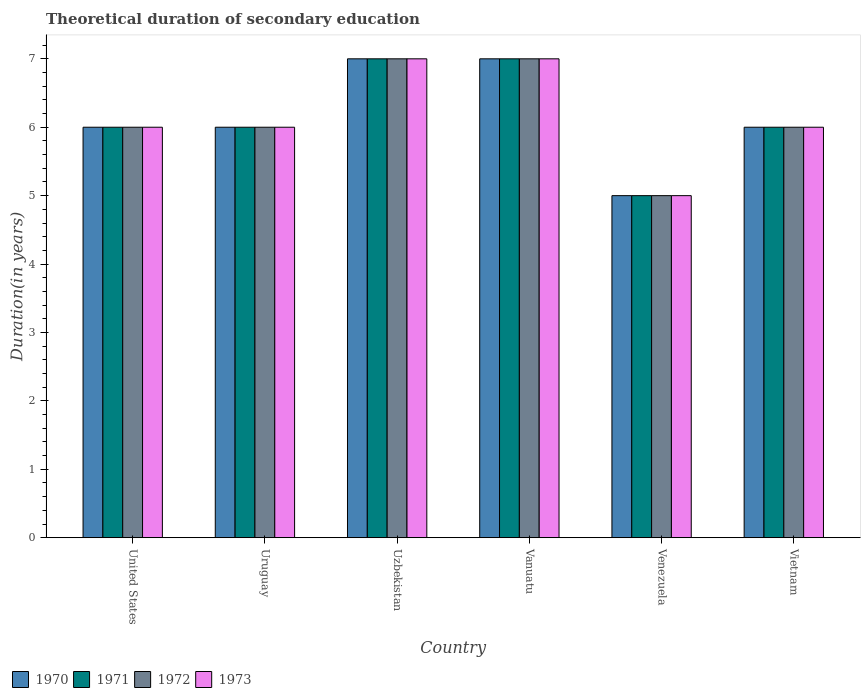How many different coloured bars are there?
Give a very brief answer. 4. Are the number of bars on each tick of the X-axis equal?
Offer a very short reply. Yes. How many bars are there on the 6th tick from the left?
Make the answer very short. 4. What is the label of the 3rd group of bars from the left?
Your response must be concise. Uzbekistan. In how many cases, is the number of bars for a given country not equal to the number of legend labels?
Offer a very short reply. 0. What is the total theoretical duration of secondary education in 1973 in Vietnam?
Provide a succinct answer. 6. Across all countries, what is the maximum total theoretical duration of secondary education in 1972?
Offer a terse response. 7. Across all countries, what is the minimum total theoretical duration of secondary education in 1971?
Provide a short and direct response. 5. In which country was the total theoretical duration of secondary education in 1971 maximum?
Keep it short and to the point. Uzbekistan. In which country was the total theoretical duration of secondary education in 1971 minimum?
Give a very brief answer. Venezuela. What is the total total theoretical duration of secondary education in 1973 in the graph?
Provide a short and direct response. 37. What is the difference between the total theoretical duration of secondary education in 1970 in United States and that in Vietnam?
Give a very brief answer. 0. What is the difference between the total theoretical duration of secondary education in 1971 in Vietnam and the total theoretical duration of secondary education in 1970 in United States?
Ensure brevity in your answer.  0. What is the average total theoretical duration of secondary education in 1970 per country?
Your answer should be compact. 6.17. In how many countries, is the total theoretical duration of secondary education in 1971 greater than 3.4 years?
Your answer should be very brief. 6. What is the ratio of the total theoretical duration of secondary education in 1972 in Vanuatu to that in Vietnam?
Provide a short and direct response. 1.17. Is the difference between the total theoretical duration of secondary education in 1971 in Vanuatu and Vietnam greater than the difference between the total theoretical duration of secondary education in 1972 in Vanuatu and Vietnam?
Your answer should be very brief. No. What is the difference between the highest and the second highest total theoretical duration of secondary education in 1972?
Offer a very short reply. -1. In how many countries, is the total theoretical duration of secondary education in 1970 greater than the average total theoretical duration of secondary education in 1970 taken over all countries?
Provide a succinct answer. 2. Is it the case that in every country, the sum of the total theoretical duration of secondary education in 1971 and total theoretical duration of secondary education in 1973 is greater than the sum of total theoretical duration of secondary education in 1972 and total theoretical duration of secondary education in 1970?
Offer a very short reply. No. What does the 3rd bar from the right in Venezuela represents?
Give a very brief answer. 1971. Are all the bars in the graph horizontal?
Give a very brief answer. No. How many countries are there in the graph?
Give a very brief answer. 6. How are the legend labels stacked?
Provide a succinct answer. Horizontal. What is the title of the graph?
Ensure brevity in your answer.  Theoretical duration of secondary education. What is the label or title of the Y-axis?
Provide a succinct answer. Duration(in years). What is the Duration(in years) in 1970 in United States?
Make the answer very short. 6. What is the Duration(in years) in 1972 in United States?
Keep it short and to the point. 6. What is the Duration(in years) in 1973 in United States?
Make the answer very short. 6. What is the Duration(in years) of 1970 in Uruguay?
Ensure brevity in your answer.  6. What is the Duration(in years) of 1972 in Vanuatu?
Offer a terse response. 7. What is the Duration(in years) of 1971 in Venezuela?
Your response must be concise. 5. What is the Duration(in years) of 1973 in Venezuela?
Keep it short and to the point. 5. What is the Duration(in years) in 1970 in Vietnam?
Your answer should be very brief. 6. What is the Duration(in years) of 1973 in Vietnam?
Your response must be concise. 6. Across all countries, what is the maximum Duration(in years) in 1970?
Provide a short and direct response. 7. Across all countries, what is the maximum Duration(in years) in 1971?
Your response must be concise. 7. Across all countries, what is the maximum Duration(in years) in 1972?
Your answer should be compact. 7. Across all countries, what is the maximum Duration(in years) in 1973?
Keep it short and to the point. 7. What is the total Duration(in years) of 1970 in the graph?
Your answer should be very brief. 37. What is the total Duration(in years) in 1971 in the graph?
Your response must be concise. 37. What is the difference between the Duration(in years) of 1972 in United States and that in Uruguay?
Offer a very short reply. 0. What is the difference between the Duration(in years) of 1973 in United States and that in Uruguay?
Ensure brevity in your answer.  0. What is the difference between the Duration(in years) in 1970 in United States and that in Uzbekistan?
Your answer should be compact. -1. What is the difference between the Duration(in years) in 1971 in United States and that in Uzbekistan?
Offer a very short reply. -1. What is the difference between the Duration(in years) of 1970 in United States and that in Vanuatu?
Make the answer very short. -1. What is the difference between the Duration(in years) in 1971 in United States and that in Vanuatu?
Offer a very short reply. -1. What is the difference between the Duration(in years) in 1973 in United States and that in Vanuatu?
Keep it short and to the point. -1. What is the difference between the Duration(in years) in 1970 in United States and that in Venezuela?
Ensure brevity in your answer.  1. What is the difference between the Duration(in years) of 1972 in United States and that in Venezuela?
Your response must be concise. 1. What is the difference between the Duration(in years) in 1973 in United States and that in Venezuela?
Your answer should be very brief. 1. What is the difference between the Duration(in years) of 1970 in United States and that in Vietnam?
Your response must be concise. 0. What is the difference between the Duration(in years) in 1971 in United States and that in Vietnam?
Provide a succinct answer. 0. What is the difference between the Duration(in years) of 1973 in United States and that in Vietnam?
Your response must be concise. 0. What is the difference between the Duration(in years) in 1972 in Uruguay and that in Uzbekistan?
Your answer should be compact. -1. What is the difference between the Duration(in years) in 1973 in Uruguay and that in Uzbekistan?
Your response must be concise. -1. What is the difference between the Duration(in years) of 1972 in Uruguay and that in Vanuatu?
Your answer should be very brief. -1. What is the difference between the Duration(in years) in 1973 in Uruguay and that in Vanuatu?
Ensure brevity in your answer.  -1. What is the difference between the Duration(in years) in 1970 in Uruguay and that in Venezuela?
Give a very brief answer. 1. What is the difference between the Duration(in years) of 1973 in Uruguay and that in Venezuela?
Keep it short and to the point. 1. What is the difference between the Duration(in years) in 1970 in Uruguay and that in Vietnam?
Keep it short and to the point. 0. What is the difference between the Duration(in years) in 1972 in Uruguay and that in Vietnam?
Your answer should be very brief. 0. What is the difference between the Duration(in years) in 1970 in Uzbekistan and that in Vanuatu?
Provide a succinct answer. 0. What is the difference between the Duration(in years) in 1971 in Uzbekistan and that in Vanuatu?
Offer a very short reply. 0. What is the difference between the Duration(in years) in 1972 in Uzbekistan and that in Vanuatu?
Offer a very short reply. 0. What is the difference between the Duration(in years) in 1973 in Uzbekistan and that in Vanuatu?
Make the answer very short. 0. What is the difference between the Duration(in years) in 1970 in Uzbekistan and that in Venezuela?
Provide a short and direct response. 2. What is the difference between the Duration(in years) of 1971 in Uzbekistan and that in Venezuela?
Offer a very short reply. 2. What is the difference between the Duration(in years) of 1972 in Uzbekistan and that in Venezuela?
Offer a terse response. 2. What is the difference between the Duration(in years) of 1970 in Vanuatu and that in Venezuela?
Provide a succinct answer. 2. What is the difference between the Duration(in years) in 1972 in Vanuatu and that in Venezuela?
Give a very brief answer. 2. What is the difference between the Duration(in years) of 1970 in Vanuatu and that in Vietnam?
Keep it short and to the point. 1. What is the difference between the Duration(in years) in 1973 in Vanuatu and that in Vietnam?
Provide a short and direct response. 1. What is the difference between the Duration(in years) in 1970 in Venezuela and that in Vietnam?
Offer a very short reply. -1. What is the difference between the Duration(in years) of 1972 in Venezuela and that in Vietnam?
Give a very brief answer. -1. What is the difference between the Duration(in years) in 1970 in United States and the Duration(in years) in 1973 in Uruguay?
Your answer should be very brief. 0. What is the difference between the Duration(in years) in 1971 in United States and the Duration(in years) in 1973 in Uruguay?
Provide a short and direct response. 0. What is the difference between the Duration(in years) of 1972 in United States and the Duration(in years) of 1973 in Uruguay?
Make the answer very short. 0. What is the difference between the Duration(in years) of 1970 in United States and the Duration(in years) of 1972 in Uzbekistan?
Keep it short and to the point. -1. What is the difference between the Duration(in years) in 1971 in United States and the Duration(in years) in 1972 in Uzbekistan?
Offer a very short reply. -1. What is the difference between the Duration(in years) in 1972 in United States and the Duration(in years) in 1973 in Uzbekistan?
Provide a short and direct response. -1. What is the difference between the Duration(in years) in 1970 in United States and the Duration(in years) in 1971 in Vanuatu?
Offer a very short reply. -1. What is the difference between the Duration(in years) in 1970 in United States and the Duration(in years) in 1972 in Vanuatu?
Your response must be concise. -1. What is the difference between the Duration(in years) in 1971 in United States and the Duration(in years) in 1972 in Vanuatu?
Ensure brevity in your answer.  -1. What is the difference between the Duration(in years) in 1971 in United States and the Duration(in years) in 1973 in Vanuatu?
Give a very brief answer. -1. What is the difference between the Duration(in years) of 1970 in United States and the Duration(in years) of 1972 in Venezuela?
Your response must be concise. 1. What is the difference between the Duration(in years) of 1970 in United States and the Duration(in years) of 1973 in Venezuela?
Ensure brevity in your answer.  1. What is the difference between the Duration(in years) of 1971 in United States and the Duration(in years) of 1972 in Venezuela?
Keep it short and to the point. 1. What is the difference between the Duration(in years) in 1972 in United States and the Duration(in years) in 1973 in Venezuela?
Your response must be concise. 1. What is the difference between the Duration(in years) of 1970 in United States and the Duration(in years) of 1971 in Vietnam?
Provide a short and direct response. 0. What is the difference between the Duration(in years) of 1970 in United States and the Duration(in years) of 1972 in Vietnam?
Keep it short and to the point. 0. What is the difference between the Duration(in years) in 1971 in United States and the Duration(in years) in 1972 in Vietnam?
Provide a succinct answer. 0. What is the difference between the Duration(in years) in 1970 in Uruguay and the Duration(in years) in 1971 in Uzbekistan?
Keep it short and to the point. -1. What is the difference between the Duration(in years) of 1970 in Uruguay and the Duration(in years) of 1972 in Uzbekistan?
Ensure brevity in your answer.  -1. What is the difference between the Duration(in years) in 1971 in Uruguay and the Duration(in years) in 1973 in Uzbekistan?
Make the answer very short. -1. What is the difference between the Duration(in years) of 1970 in Uruguay and the Duration(in years) of 1971 in Vanuatu?
Offer a very short reply. -1. What is the difference between the Duration(in years) of 1970 in Uruguay and the Duration(in years) of 1972 in Vanuatu?
Your answer should be very brief. -1. What is the difference between the Duration(in years) in 1972 in Uruguay and the Duration(in years) in 1973 in Vanuatu?
Your response must be concise. -1. What is the difference between the Duration(in years) in 1970 in Uruguay and the Duration(in years) in 1972 in Venezuela?
Your answer should be very brief. 1. What is the difference between the Duration(in years) of 1971 in Uruguay and the Duration(in years) of 1972 in Venezuela?
Make the answer very short. 1. What is the difference between the Duration(in years) in 1972 in Uruguay and the Duration(in years) in 1973 in Venezuela?
Ensure brevity in your answer.  1. What is the difference between the Duration(in years) of 1970 in Uruguay and the Duration(in years) of 1972 in Vietnam?
Offer a very short reply. 0. What is the difference between the Duration(in years) in 1971 in Uruguay and the Duration(in years) in 1973 in Vietnam?
Your answer should be very brief. 0. What is the difference between the Duration(in years) of 1971 in Uzbekistan and the Duration(in years) of 1973 in Vanuatu?
Your response must be concise. 0. What is the difference between the Duration(in years) of 1970 in Uzbekistan and the Duration(in years) of 1972 in Venezuela?
Keep it short and to the point. 2. What is the difference between the Duration(in years) in 1970 in Uzbekistan and the Duration(in years) in 1973 in Venezuela?
Offer a terse response. 2. What is the difference between the Duration(in years) of 1970 in Uzbekistan and the Duration(in years) of 1972 in Vietnam?
Give a very brief answer. 1. What is the difference between the Duration(in years) of 1970 in Uzbekistan and the Duration(in years) of 1973 in Vietnam?
Make the answer very short. 1. What is the difference between the Duration(in years) in 1971 in Uzbekistan and the Duration(in years) in 1972 in Vietnam?
Provide a short and direct response. 1. What is the difference between the Duration(in years) of 1972 in Uzbekistan and the Duration(in years) of 1973 in Vietnam?
Provide a succinct answer. 1. What is the difference between the Duration(in years) in 1970 in Vanuatu and the Duration(in years) in 1972 in Venezuela?
Keep it short and to the point. 2. What is the difference between the Duration(in years) in 1971 in Vanuatu and the Duration(in years) in 1973 in Venezuela?
Provide a succinct answer. 2. What is the difference between the Duration(in years) of 1972 in Vanuatu and the Duration(in years) of 1973 in Venezuela?
Offer a very short reply. 2. What is the difference between the Duration(in years) in 1970 in Vanuatu and the Duration(in years) in 1972 in Vietnam?
Offer a very short reply. 1. What is the difference between the Duration(in years) of 1971 in Vanuatu and the Duration(in years) of 1972 in Vietnam?
Make the answer very short. 1. What is the difference between the Duration(in years) of 1972 in Vanuatu and the Duration(in years) of 1973 in Vietnam?
Make the answer very short. 1. What is the difference between the Duration(in years) of 1970 in Venezuela and the Duration(in years) of 1971 in Vietnam?
Give a very brief answer. -1. What is the difference between the Duration(in years) in 1970 in Venezuela and the Duration(in years) in 1972 in Vietnam?
Give a very brief answer. -1. What is the difference between the Duration(in years) in 1971 in Venezuela and the Duration(in years) in 1972 in Vietnam?
Your response must be concise. -1. What is the difference between the Duration(in years) in 1971 in Venezuela and the Duration(in years) in 1973 in Vietnam?
Your answer should be very brief. -1. What is the average Duration(in years) in 1970 per country?
Make the answer very short. 6.17. What is the average Duration(in years) of 1971 per country?
Offer a very short reply. 6.17. What is the average Duration(in years) of 1972 per country?
Your answer should be very brief. 6.17. What is the average Duration(in years) in 1973 per country?
Ensure brevity in your answer.  6.17. What is the difference between the Duration(in years) in 1970 and Duration(in years) in 1971 in United States?
Offer a very short reply. 0. What is the difference between the Duration(in years) of 1970 and Duration(in years) of 1973 in United States?
Your answer should be very brief. 0. What is the difference between the Duration(in years) in 1972 and Duration(in years) in 1973 in Uruguay?
Give a very brief answer. 0. What is the difference between the Duration(in years) in 1970 and Duration(in years) in 1973 in Uzbekistan?
Make the answer very short. 0. What is the difference between the Duration(in years) in 1971 and Duration(in years) in 1972 in Uzbekistan?
Your answer should be compact. 0. What is the difference between the Duration(in years) in 1972 and Duration(in years) in 1973 in Uzbekistan?
Offer a very short reply. 0. What is the difference between the Duration(in years) of 1970 and Duration(in years) of 1971 in Vanuatu?
Provide a short and direct response. 0. What is the difference between the Duration(in years) of 1971 and Duration(in years) of 1972 in Vanuatu?
Your answer should be very brief. 0. What is the difference between the Duration(in years) in 1972 and Duration(in years) in 1973 in Vanuatu?
Offer a very short reply. 0. What is the difference between the Duration(in years) in 1970 and Duration(in years) in 1971 in Venezuela?
Provide a succinct answer. 0. What is the difference between the Duration(in years) of 1970 and Duration(in years) of 1972 in Venezuela?
Provide a succinct answer. 0. What is the difference between the Duration(in years) of 1971 and Duration(in years) of 1972 in Venezuela?
Offer a very short reply. 0. What is the difference between the Duration(in years) of 1972 and Duration(in years) of 1973 in Venezuela?
Make the answer very short. 0. What is the difference between the Duration(in years) of 1970 and Duration(in years) of 1971 in Vietnam?
Provide a short and direct response. 0. What is the difference between the Duration(in years) in 1971 and Duration(in years) in 1973 in Vietnam?
Your answer should be very brief. 0. What is the ratio of the Duration(in years) in 1971 in United States to that in Uruguay?
Your answer should be very brief. 1. What is the ratio of the Duration(in years) in 1972 in United States to that in Uruguay?
Your answer should be very brief. 1. What is the ratio of the Duration(in years) in 1970 in United States to that in Uzbekistan?
Your answer should be very brief. 0.86. What is the ratio of the Duration(in years) in 1972 in United States to that in Uzbekistan?
Keep it short and to the point. 0.86. What is the ratio of the Duration(in years) of 1971 in United States to that in Vanuatu?
Make the answer very short. 0.86. What is the ratio of the Duration(in years) in 1972 in United States to that in Vanuatu?
Provide a short and direct response. 0.86. What is the ratio of the Duration(in years) in 1973 in United States to that in Vanuatu?
Make the answer very short. 0.86. What is the ratio of the Duration(in years) of 1970 in United States to that in Venezuela?
Offer a very short reply. 1.2. What is the ratio of the Duration(in years) of 1971 in United States to that in Venezuela?
Offer a terse response. 1.2. What is the ratio of the Duration(in years) in 1972 in United States to that in Venezuela?
Your response must be concise. 1.2. What is the ratio of the Duration(in years) of 1973 in United States to that in Venezuela?
Your answer should be compact. 1.2. What is the ratio of the Duration(in years) in 1971 in United States to that in Vietnam?
Keep it short and to the point. 1. What is the ratio of the Duration(in years) of 1971 in Uruguay to that in Uzbekistan?
Give a very brief answer. 0.86. What is the ratio of the Duration(in years) in 1973 in Uruguay to that in Uzbekistan?
Offer a very short reply. 0.86. What is the ratio of the Duration(in years) of 1970 in Uruguay to that in Vanuatu?
Provide a succinct answer. 0.86. What is the ratio of the Duration(in years) in 1971 in Uruguay to that in Vanuatu?
Ensure brevity in your answer.  0.86. What is the ratio of the Duration(in years) in 1972 in Uruguay to that in Vanuatu?
Your answer should be very brief. 0.86. What is the ratio of the Duration(in years) in 1971 in Uruguay to that in Venezuela?
Offer a terse response. 1.2. What is the ratio of the Duration(in years) in 1973 in Uruguay to that in Venezuela?
Your answer should be very brief. 1.2. What is the ratio of the Duration(in years) of 1972 in Uruguay to that in Vietnam?
Provide a succinct answer. 1. What is the ratio of the Duration(in years) in 1970 in Uzbekistan to that in Vanuatu?
Offer a terse response. 1. What is the ratio of the Duration(in years) in 1970 in Uzbekistan to that in Venezuela?
Provide a succinct answer. 1.4. What is the ratio of the Duration(in years) of 1971 in Uzbekistan to that in Venezuela?
Make the answer very short. 1.4. What is the ratio of the Duration(in years) in 1971 in Vanuatu to that in Venezuela?
Your answer should be very brief. 1.4. What is the ratio of the Duration(in years) in 1972 in Vanuatu to that in Vietnam?
Give a very brief answer. 1.17. What is the ratio of the Duration(in years) of 1971 in Venezuela to that in Vietnam?
Offer a very short reply. 0.83. What is the ratio of the Duration(in years) of 1973 in Venezuela to that in Vietnam?
Your response must be concise. 0.83. What is the difference between the highest and the second highest Duration(in years) in 1970?
Ensure brevity in your answer.  0. What is the difference between the highest and the second highest Duration(in years) of 1971?
Keep it short and to the point. 0. What is the difference between the highest and the second highest Duration(in years) of 1973?
Provide a short and direct response. 0. What is the difference between the highest and the lowest Duration(in years) of 1971?
Keep it short and to the point. 2. What is the difference between the highest and the lowest Duration(in years) of 1972?
Your answer should be compact. 2. What is the difference between the highest and the lowest Duration(in years) in 1973?
Provide a succinct answer. 2. 